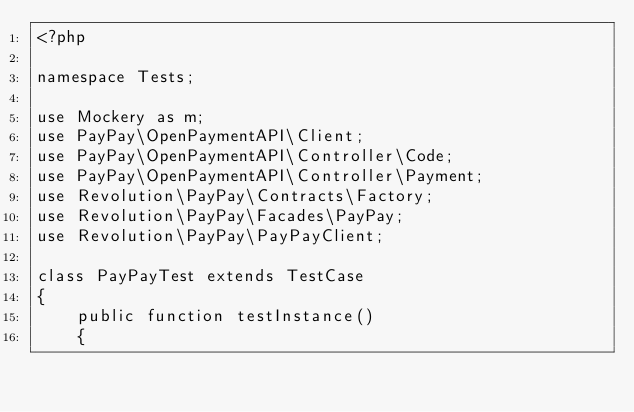Convert code to text. <code><loc_0><loc_0><loc_500><loc_500><_PHP_><?php

namespace Tests;

use Mockery as m;
use PayPay\OpenPaymentAPI\Client;
use PayPay\OpenPaymentAPI\Controller\Code;
use PayPay\OpenPaymentAPI\Controller\Payment;
use Revolution\PayPay\Contracts\Factory;
use Revolution\PayPay\Facades\PayPay;
use Revolution\PayPay\PayPayClient;

class PayPayTest extends TestCase
{
    public function testInstance()
    {</code> 